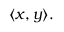Convert formula to latex. <formula><loc_0><loc_0><loc_500><loc_500>\langle x , y \rangle .</formula> 